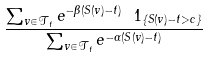Convert formula to latex. <formula><loc_0><loc_0><loc_500><loc_500>\frac { \sum _ { v \in \mathcal { T } _ { t } } e ^ { - \beta ( S ( v ) - t ) } \ 1 _ { \{ S ( v ) - t > c \} } } { \sum _ { v \in \mathcal { T } _ { t } } e ^ { - \alpha ( S ( v ) - t ) } }</formula> 